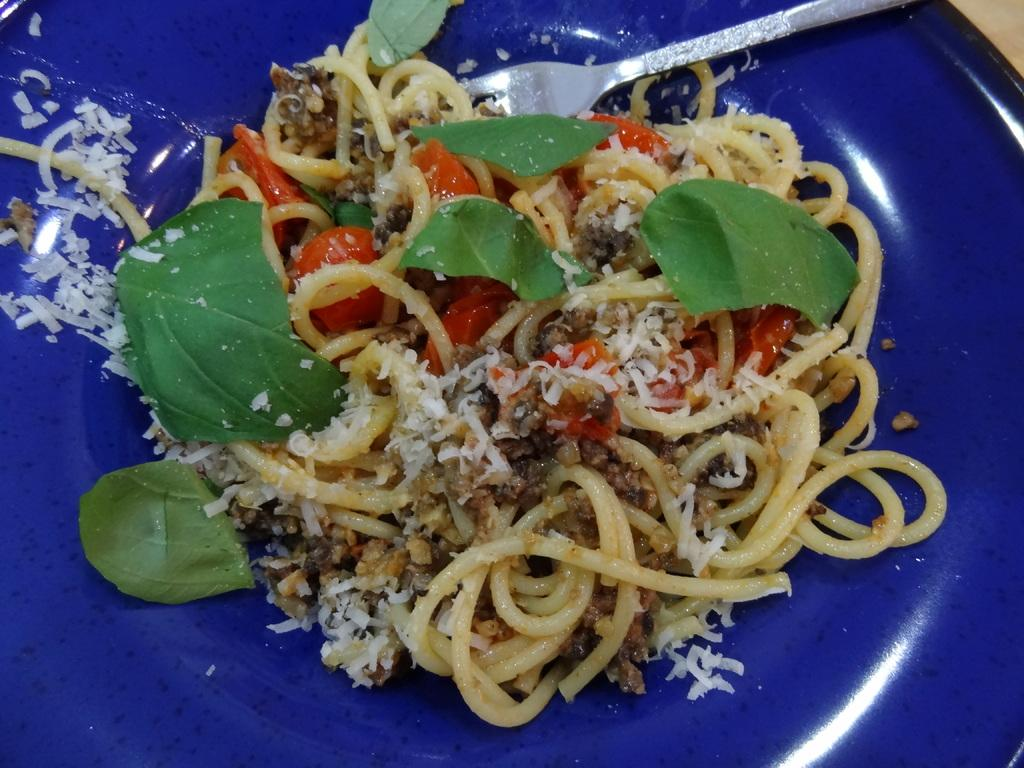What type of food is visible in the image? There are noodles in the image. What utensil is present in the image? There is a fork in the image. What type of vegetation can be seen in the image? There are leaves in the image. What else is on the plate in the image besides noodles? There is other food in the plate in the image. How many seas can be seen in the image? There are no seas present in the image. What is the fifth item on the plate in the image? There is no fifth item on the plate in the image, as only noodles and other food are mentioned in the provided facts. 